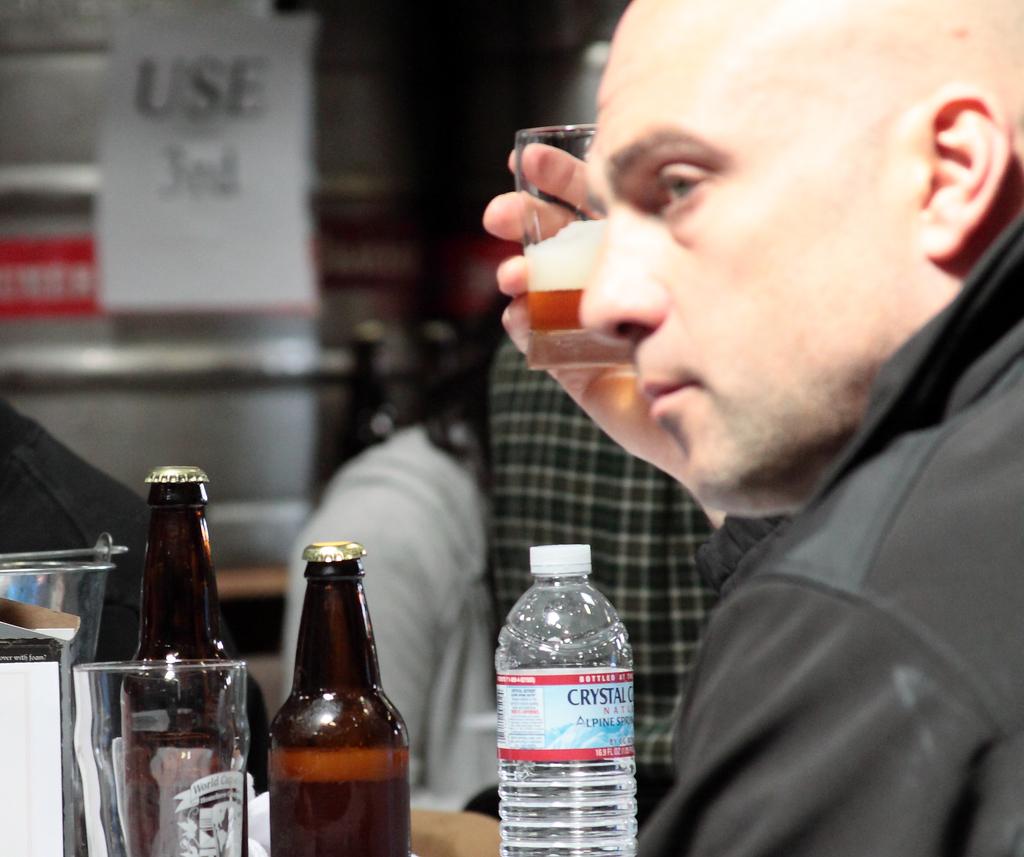What is the first word of the brand name on the water bottle?
Provide a short and direct response. Crystal. 